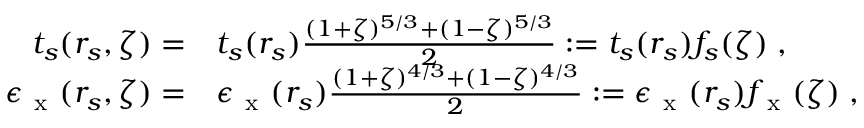Convert formula to latex. <formula><loc_0><loc_0><loc_500><loc_500>\begin{array} { r l } { t _ { s } ( r _ { s } , \zeta ) = } & t _ { s } ( r _ { s } ) \frac { ( 1 + \zeta ) ^ { 5 / 3 } + ( 1 - \zeta ) ^ { 5 / 3 } } { 2 } \colon = t _ { s } ( r _ { s } ) f _ { s } ( \zeta ) \, , } \\ { \epsilon _ { x } ( r _ { s } , \zeta ) = } & \epsilon _ { x } ( r _ { s } ) \frac { ( 1 + \zeta ) ^ { 4 / 3 } + ( 1 - \zeta ) ^ { 4 / 3 } } { 2 } \colon = \epsilon _ { x } ( r _ { s } ) f _ { x } ( \zeta ) \, , } \end{array}</formula> 